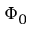<formula> <loc_0><loc_0><loc_500><loc_500>\Phi _ { 0 }</formula> 